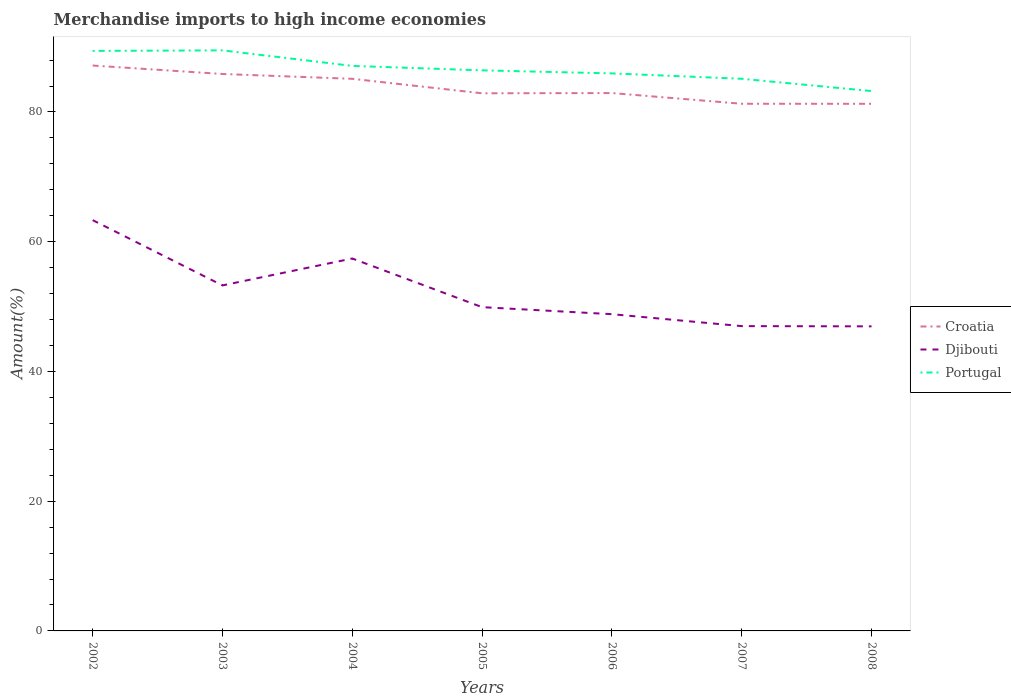How many different coloured lines are there?
Make the answer very short. 3. Is the number of lines equal to the number of legend labels?
Offer a terse response. Yes. Across all years, what is the maximum percentage of amount earned from merchandise imports in Djibouti?
Offer a very short reply. 46.95. In which year was the percentage of amount earned from merchandise imports in Croatia maximum?
Provide a short and direct response. 2008. What is the total percentage of amount earned from merchandise imports in Portugal in the graph?
Provide a succinct answer. 6.27. What is the difference between the highest and the second highest percentage of amount earned from merchandise imports in Portugal?
Offer a very short reply. 6.27. What is the difference between the highest and the lowest percentage of amount earned from merchandise imports in Djibouti?
Your answer should be compact. 3. What is the difference between two consecutive major ticks on the Y-axis?
Ensure brevity in your answer.  20. Are the values on the major ticks of Y-axis written in scientific E-notation?
Keep it short and to the point. No. Where does the legend appear in the graph?
Your response must be concise. Center right. How many legend labels are there?
Keep it short and to the point. 3. How are the legend labels stacked?
Provide a short and direct response. Vertical. What is the title of the graph?
Ensure brevity in your answer.  Merchandise imports to high income economies. Does "Mexico" appear as one of the legend labels in the graph?
Keep it short and to the point. No. What is the label or title of the X-axis?
Keep it short and to the point. Years. What is the label or title of the Y-axis?
Give a very brief answer. Amount(%). What is the Amount(%) of Croatia in 2002?
Ensure brevity in your answer.  87.16. What is the Amount(%) in Djibouti in 2002?
Your answer should be very brief. 63.33. What is the Amount(%) in Portugal in 2002?
Keep it short and to the point. 89.41. What is the Amount(%) in Croatia in 2003?
Make the answer very short. 85.85. What is the Amount(%) of Djibouti in 2003?
Keep it short and to the point. 53.26. What is the Amount(%) in Portugal in 2003?
Keep it short and to the point. 89.5. What is the Amount(%) in Croatia in 2004?
Give a very brief answer. 85.11. What is the Amount(%) of Djibouti in 2004?
Your answer should be compact. 57.41. What is the Amount(%) in Portugal in 2004?
Provide a succinct answer. 87.1. What is the Amount(%) in Croatia in 2005?
Provide a short and direct response. 82.88. What is the Amount(%) in Djibouti in 2005?
Provide a short and direct response. 49.91. What is the Amount(%) of Portugal in 2005?
Your answer should be compact. 86.41. What is the Amount(%) in Croatia in 2006?
Ensure brevity in your answer.  82.92. What is the Amount(%) in Djibouti in 2006?
Ensure brevity in your answer.  48.83. What is the Amount(%) of Portugal in 2006?
Offer a very short reply. 85.95. What is the Amount(%) of Croatia in 2007?
Keep it short and to the point. 81.27. What is the Amount(%) in Djibouti in 2007?
Provide a succinct answer. 46.99. What is the Amount(%) in Portugal in 2007?
Ensure brevity in your answer.  85.12. What is the Amount(%) of Croatia in 2008?
Make the answer very short. 81.26. What is the Amount(%) in Djibouti in 2008?
Provide a short and direct response. 46.95. What is the Amount(%) in Portugal in 2008?
Your answer should be compact. 83.22. Across all years, what is the maximum Amount(%) in Croatia?
Ensure brevity in your answer.  87.16. Across all years, what is the maximum Amount(%) of Djibouti?
Offer a very short reply. 63.33. Across all years, what is the maximum Amount(%) in Portugal?
Ensure brevity in your answer.  89.5. Across all years, what is the minimum Amount(%) in Croatia?
Your answer should be compact. 81.26. Across all years, what is the minimum Amount(%) in Djibouti?
Make the answer very short. 46.95. Across all years, what is the minimum Amount(%) in Portugal?
Offer a very short reply. 83.22. What is the total Amount(%) of Croatia in the graph?
Make the answer very short. 586.45. What is the total Amount(%) of Djibouti in the graph?
Your answer should be compact. 366.68. What is the total Amount(%) in Portugal in the graph?
Provide a short and direct response. 606.71. What is the difference between the Amount(%) in Croatia in 2002 and that in 2003?
Make the answer very short. 1.3. What is the difference between the Amount(%) of Djibouti in 2002 and that in 2003?
Make the answer very short. 10.06. What is the difference between the Amount(%) of Portugal in 2002 and that in 2003?
Give a very brief answer. -0.08. What is the difference between the Amount(%) in Croatia in 2002 and that in 2004?
Your answer should be very brief. 2.05. What is the difference between the Amount(%) of Djibouti in 2002 and that in 2004?
Offer a very short reply. 5.92. What is the difference between the Amount(%) of Portugal in 2002 and that in 2004?
Your answer should be compact. 2.31. What is the difference between the Amount(%) of Croatia in 2002 and that in 2005?
Provide a succinct answer. 4.28. What is the difference between the Amount(%) in Djibouti in 2002 and that in 2005?
Ensure brevity in your answer.  13.41. What is the difference between the Amount(%) in Portugal in 2002 and that in 2005?
Your response must be concise. 3. What is the difference between the Amount(%) in Croatia in 2002 and that in 2006?
Provide a short and direct response. 4.24. What is the difference between the Amount(%) in Djibouti in 2002 and that in 2006?
Ensure brevity in your answer.  14.5. What is the difference between the Amount(%) in Portugal in 2002 and that in 2006?
Your answer should be compact. 3.46. What is the difference between the Amount(%) in Croatia in 2002 and that in 2007?
Provide a short and direct response. 5.89. What is the difference between the Amount(%) in Djibouti in 2002 and that in 2007?
Provide a short and direct response. 16.34. What is the difference between the Amount(%) of Portugal in 2002 and that in 2007?
Keep it short and to the point. 4.29. What is the difference between the Amount(%) of Croatia in 2002 and that in 2008?
Provide a short and direct response. 5.9. What is the difference between the Amount(%) in Djibouti in 2002 and that in 2008?
Offer a very short reply. 16.37. What is the difference between the Amount(%) of Portugal in 2002 and that in 2008?
Your answer should be compact. 6.19. What is the difference between the Amount(%) in Croatia in 2003 and that in 2004?
Provide a short and direct response. 0.74. What is the difference between the Amount(%) of Djibouti in 2003 and that in 2004?
Your response must be concise. -4.15. What is the difference between the Amount(%) of Portugal in 2003 and that in 2004?
Your answer should be compact. 2.39. What is the difference between the Amount(%) in Croatia in 2003 and that in 2005?
Offer a terse response. 2.97. What is the difference between the Amount(%) of Djibouti in 2003 and that in 2005?
Keep it short and to the point. 3.35. What is the difference between the Amount(%) of Portugal in 2003 and that in 2005?
Keep it short and to the point. 3.08. What is the difference between the Amount(%) of Croatia in 2003 and that in 2006?
Offer a terse response. 2.94. What is the difference between the Amount(%) of Djibouti in 2003 and that in 2006?
Keep it short and to the point. 4.43. What is the difference between the Amount(%) in Portugal in 2003 and that in 2006?
Your response must be concise. 3.55. What is the difference between the Amount(%) in Croatia in 2003 and that in 2007?
Provide a short and direct response. 4.59. What is the difference between the Amount(%) of Djibouti in 2003 and that in 2007?
Provide a succinct answer. 6.28. What is the difference between the Amount(%) in Portugal in 2003 and that in 2007?
Offer a very short reply. 4.38. What is the difference between the Amount(%) of Croatia in 2003 and that in 2008?
Provide a short and direct response. 4.6. What is the difference between the Amount(%) in Djibouti in 2003 and that in 2008?
Offer a very short reply. 6.31. What is the difference between the Amount(%) in Portugal in 2003 and that in 2008?
Offer a very short reply. 6.27. What is the difference between the Amount(%) in Croatia in 2004 and that in 2005?
Offer a terse response. 2.23. What is the difference between the Amount(%) in Djibouti in 2004 and that in 2005?
Offer a terse response. 7.5. What is the difference between the Amount(%) in Portugal in 2004 and that in 2005?
Make the answer very short. 0.69. What is the difference between the Amount(%) of Croatia in 2004 and that in 2006?
Provide a short and direct response. 2.2. What is the difference between the Amount(%) in Djibouti in 2004 and that in 2006?
Your response must be concise. 8.58. What is the difference between the Amount(%) in Portugal in 2004 and that in 2006?
Your answer should be very brief. 1.15. What is the difference between the Amount(%) of Croatia in 2004 and that in 2007?
Give a very brief answer. 3.85. What is the difference between the Amount(%) of Djibouti in 2004 and that in 2007?
Your answer should be compact. 10.42. What is the difference between the Amount(%) in Portugal in 2004 and that in 2007?
Provide a succinct answer. 1.98. What is the difference between the Amount(%) of Croatia in 2004 and that in 2008?
Your answer should be very brief. 3.85. What is the difference between the Amount(%) of Djibouti in 2004 and that in 2008?
Make the answer very short. 10.46. What is the difference between the Amount(%) of Portugal in 2004 and that in 2008?
Your answer should be compact. 3.88. What is the difference between the Amount(%) in Croatia in 2005 and that in 2006?
Provide a short and direct response. -0.04. What is the difference between the Amount(%) in Djibouti in 2005 and that in 2006?
Offer a very short reply. 1.08. What is the difference between the Amount(%) in Portugal in 2005 and that in 2006?
Provide a succinct answer. 0.47. What is the difference between the Amount(%) of Croatia in 2005 and that in 2007?
Give a very brief answer. 1.61. What is the difference between the Amount(%) of Djibouti in 2005 and that in 2007?
Ensure brevity in your answer.  2.93. What is the difference between the Amount(%) in Portugal in 2005 and that in 2007?
Your response must be concise. 1.3. What is the difference between the Amount(%) in Croatia in 2005 and that in 2008?
Offer a terse response. 1.62. What is the difference between the Amount(%) in Djibouti in 2005 and that in 2008?
Ensure brevity in your answer.  2.96. What is the difference between the Amount(%) in Portugal in 2005 and that in 2008?
Ensure brevity in your answer.  3.19. What is the difference between the Amount(%) in Croatia in 2006 and that in 2007?
Ensure brevity in your answer.  1.65. What is the difference between the Amount(%) of Djibouti in 2006 and that in 2007?
Provide a succinct answer. 1.84. What is the difference between the Amount(%) in Portugal in 2006 and that in 2007?
Your answer should be very brief. 0.83. What is the difference between the Amount(%) of Croatia in 2006 and that in 2008?
Your response must be concise. 1.66. What is the difference between the Amount(%) of Djibouti in 2006 and that in 2008?
Provide a succinct answer. 1.88. What is the difference between the Amount(%) in Portugal in 2006 and that in 2008?
Your answer should be compact. 2.72. What is the difference between the Amount(%) of Croatia in 2007 and that in 2008?
Provide a succinct answer. 0.01. What is the difference between the Amount(%) of Djibouti in 2007 and that in 2008?
Ensure brevity in your answer.  0.04. What is the difference between the Amount(%) in Portugal in 2007 and that in 2008?
Keep it short and to the point. 1.89. What is the difference between the Amount(%) of Croatia in 2002 and the Amount(%) of Djibouti in 2003?
Keep it short and to the point. 33.9. What is the difference between the Amount(%) in Croatia in 2002 and the Amount(%) in Portugal in 2003?
Your response must be concise. -2.34. What is the difference between the Amount(%) of Djibouti in 2002 and the Amount(%) of Portugal in 2003?
Provide a short and direct response. -26.17. What is the difference between the Amount(%) of Croatia in 2002 and the Amount(%) of Djibouti in 2004?
Make the answer very short. 29.75. What is the difference between the Amount(%) of Croatia in 2002 and the Amount(%) of Portugal in 2004?
Offer a terse response. 0.06. What is the difference between the Amount(%) in Djibouti in 2002 and the Amount(%) in Portugal in 2004?
Your response must be concise. -23.78. What is the difference between the Amount(%) of Croatia in 2002 and the Amount(%) of Djibouti in 2005?
Your response must be concise. 37.25. What is the difference between the Amount(%) in Croatia in 2002 and the Amount(%) in Portugal in 2005?
Ensure brevity in your answer.  0.74. What is the difference between the Amount(%) in Djibouti in 2002 and the Amount(%) in Portugal in 2005?
Your answer should be compact. -23.09. What is the difference between the Amount(%) in Croatia in 2002 and the Amount(%) in Djibouti in 2006?
Provide a succinct answer. 38.33. What is the difference between the Amount(%) in Croatia in 2002 and the Amount(%) in Portugal in 2006?
Keep it short and to the point. 1.21. What is the difference between the Amount(%) of Djibouti in 2002 and the Amount(%) of Portugal in 2006?
Ensure brevity in your answer.  -22.62. What is the difference between the Amount(%) in Croatia in 2002 and the Amount(%) in Djibouti in 2007?
Offer a very short reply. 40.17. What is the difference between the Amount(%) in Croatia in 2002 and the Amount(%) in Portugal in 2007?
Offer a terse response. 2.04. What is the difference between the Amount(%) of Djibouti in 2002 and the Amount(%) of Portugal in 2007?
Your answer should be compact. -21.79. What is the difference between the Amount(%) in Croatia in 2002 and the Amount(%) in Djibouti in 2008?
Your answer should be compact. 40.21. What is the difference between the Amount(%) in Croatia in 2002 and the Amount(%) in Portugal in 2008?
Provide a short and direct response. 3.94. What is the difference between the Amount(%) of Djibouti in 2002 and the Amount(%) of Portugal in 2008?
Your answer should be very brief. -19.9. What is the difference between the Amount(%) of Croatia in 2003 and the Amount(%) of Djibouti in 2004?
Offer a terse response. 28.44. What is the difference between the Amount(%) of Croatia in 2003 and the Amount(%) of Portugal in 2004?
Provide a short and direct response. -1.25. What is the difference between the Amount(%) of Djibouti in 2003 and the Amount(%) of Portugal in 2004?
Your response must be concise. -33.84. What is the difference between the Amount(%) of Croatia in 2003 and the Amount(%) of Djibouti in 2005?
Offer a very short reply. 35.94. What is the difference between the Amount(%) in Croatia in 2003 and the Amount(%) in Portugal in 2005?
Your answer should be compact. -0.56. What is the difference between the Amount(%) of Djibouti in 2003 and the Amount(%) of Portugal in 2005?
Your response must be concise. -33.15. What is the difference between the Amount(%) of Croatia in 2003 and the Amount(%) of Djibouti in 2006?
Give a very brief answer. 37.03. What is the difference between the Amount(%) in Croatia in 2003 and the Amount(%) in Portugal in 2006?
Ensure brevity in your answer.  -0.09. What is the difference between the Amount(%) of Djibouti in 2003 and the Amount(%) of Portugal in 2006?
Offer a terse response. -32.69. What is the difference between the Amount(%) in Croatia in 2003 and the Amount(%) in Djibouti in 2007?
Offer a very short reply. 38.87. What is the difference between the Amount(%) in Croatia in 2003 and the Amount(%) in Portugal in 2007?
Your response must be concise. 0.74. What is the difference between the Amount(%) in Djibouti in 2003 and the Amount(%) in Portugal in 2007?
Give a very brief answer. -31.85. What is the difference between the Amount(%) of Croatia in 2003 and the Amount(%) of Djibouti in 2008?
Your response must be concise. 38.9. What is the difference between the Amount(%) of Croatia in 2003 and the Amount(%) of Portugal in 2008?
Offer a very short reply. 2.63. What is the difference between the Amount(%) of Djibouti in 2003 and the Amount(%) of Portugal in 2008?
Provide a short and direct response. -29.96. What is the difference between the Amount(%) in Croatia in 2004 and the Amount(%) in Djibouti in 2005?
Offer a very short reply. 35.2. What is the difference between the Amount(%) in Croatia in 2004 and the Amount(%) in Portugal in 2005?
Your response must be concise. -1.3. What is the difference between the Amount(%) of Djibouti in 2004 and the Amount(%) of Portugal in 2005?
Provide a short and direct response. -29.01. What is the difference between the Amount(%) in Croatia in 2004 and the Amount(%) in Djibouti in 2006?
Give a very brief answer. 36.28. What is the difference between the Amount(%) in Croatia in 2004 and the Amount(%) in Portugal in 2006?
Offer a very short reply. -0.84. What is the difference between the Amount(%) in Djibouti in 2004 and the Amount(%) in Portugal in 2006?
Your answer should be very brief. -28.54. What is the difference between the Amount(%) of Croatia in 2004 and the Amount(%) of Djibouti in 2007?
Keep it short and to the point. 38.13. What is the difference between the Amount(%) of Croatia in 2004 and the Amount(%) of Portugal in 2007?
Your answer should be very brief. -0. What is the difference between the Amount(%) of Djibouti in 2004 and the Amount(%) of Portugal in 2007?
Provide a short and direct response. -27.71. What is the difference between the Amount(%) of Croatia in 2004 and the Amount(%) of Djibouti in 2008?
Ensure brevity in your answer.  38.16. What is the difference between the Amount(%) of Croatia in 2004 and the Amount(%) of Portugal in 2008?
Provide a succinct answer. 1.89. What is the difference between the Amount(%) of Djibouti in 2004 and the Amount(%) of Portugal in 2008?
Give a very brief answer. -25.81. What is the difference between the Amount(%) of Croatia in 2005 and the Amount(%) of Djibouti in 2006?
Your answer should be compact. 34.05. What is the difference between the Amount(%) in Croatia in 2005 and the Amount(%) in Portugal in 2006?
Ensure brevity in your answer.  -3.07. What is the difference between the Amount(%) in Djibouti in 2005 and the Amount(%) in Portugal in 2006?
Your answer should be very brief. -36.04. What is the difference between the Amount(%) of Croatia in 2005 and the Amount(%) of Djibouti in 2007?
Give a very brief answer. 35.89. What is the difference between the Amount(%) in Croatia in 2005 and the Amount(%) in Portugal in 2007?
Keep it short and to the point. -2.24. What is the difference between the Amount(%) in Djibouti in 2005 and the Amount(%) in Portugal in 2007?
Give a very brief answer. -35.2. What is the difference between the Amount(%) of Croatia in 2005 and the Amount(%) of Djibouti in 2008?
Your answer should be very brief. 35.93. What is the difference between the Amount(%) in Croatia in 2005 and the Amount(%) in Portugal in 2008?
Give a very brief answer. -0.34. What is the difference between the Amount(%) in Djibouti in 2005 and the Amount(%) in Portugal in 2008?
Offer a very short reply. -33.31. What is the difference between the Amount(%) of Croatia in 2006 and the Amount(%) of Djibouti in 2007?
Make the answer very short. 35.93. What is the difference between the Amount(%) of Croatia in 2006 and the Amount(%) of Portugal in 2007?
Provide a succinct answer. -2.2. What is the difference between the Amount(%) of Djibouti in 2006 and the Amount(%) of Portugal in 2007?
Keep it short and to the point. -36.29. What is the difference between the Amount(%) in Croatia in 2006 and the Amount(%) in Djibouti in 2008?
Your answer should be very brief. 35.96. What is the difference between the Amount(%) in Croatia in 2006 and the Amount(%) in Portugal in 2008?
Your answer should be very brief. -0.31. What is the difference between the Amount(%) of Djibouti in 2006 and the Amount(%) of Portugal in 2008?
Keep it short and to the point. -34.4. What is the difference between the Amount(%) of Croatia in 2007 and the Amount(%) of Djibouti in 2008?
Your answer should be compact. 34.31. What is the difference between the Amount(%) in Croatia in 2007 and the Amount(%) in Portugal in 2008?
Make the answer very short. -1.96. What is the difference between the Amount(%) in Djibouti in 2007 and the Amount(%) in Portugal in 2008?
Provide a succinct answer. -36.24. What is the average Amount(%) of Croatia per year?
Offer a terse response. 83.78. What is the average Amount(%) of Djibouti per year?
Make the answer very short. 52.38. What is the average Amount(%) in Portugal per year?
Give a very brief answer. 86.67. In the year 2002, what is the difference between the Amount(%) in Croatia and Amount(%) in Djibouti?
Offer a very short reply. 23.83. In the year 2002, what is the difference between the Amount(%) of Croatia and Amount(%) of Portugal?
Provide a succinct answer. -2.25. In the year 2002, what is the difference between the Amount(%) of Djibouti and Amount(%) of Portugal?
Offer a very short reply. -26.09. In the year 2003, what is the difference between the Amount(%) in Croatia and Amount(%) in Djibouti?
Give a very brief answer. 32.59. In the year 2003, what is the difference between the Amount(%) of Croatia and Amount(%) of Portugal?
Your answer should be compact. -3.64. In the year 2003, what is the difference between the Amount(%) of Djibouti and Amount(%) of Portugal?
Offer a terse response. -36.23. In the year 2004, what is the difference between the Amount(%) in Croatia and Amount(%) in Djibouti?
Provide a succinct answer. 27.7. In the year 2004, what is the difference between the Amount(%) of Croatia and Amount(%) of Portugal?
Your answer should be compact. -1.99. In the year 2004, what is the difference between the Amount(%) of Djibouti and Amount(%) of Portugal?
Provide a succinct answer. -29.69. In the year 2005, what is the difference between the Amount(%) in Croatia and Amount(%) in Djibouti?
Offer a very short reply. 32.97. In the year 2005, what is the difference between the Amount(%) of Croatia and Amount(%) of Portugal?
Offer a terse response. -3.53. In the year 2005, what is the difference between the Amount(%) in Djibouti and Amount(%) in Portugal?
Your response must be concise. -36.5. In the year 2006, what is the difference between the Amount(%) in Croatia and Amount(%) in Djibouti?
Give a very brief answer. 34.09. In the year 2006, what is the difference between the Amount(%) in Croatia and Amount(%) in Portugal?
Offer a very short reply. -3.03. In the year 2006, what is the difference between the Amount(%) of Djibouti and Amount(%) of Portugal?
Your answer should be compact. -37.12. In the year 2007, what is the difference between the Amount(%) in Croatia and Amount(%) in Djibouti?
Your answer should be compact. 34.28. In the year 2007, what is the difference between the Amount(%) in Croatia and Amount(%) in Portugal?
Make the answer very short. -3.85. In the year 2007, what is the difference between the Amount(%) of Djibouti and Amount(%) of Portugal?
Keep it short and to the point. -38.13. In the year 2008, what is the difference between the Amount(%) in Croatia and Amount(%) in Djibouti?
Make the answer very short. 34.31. In the year 2008, what is the difference between the Amount(%) in Croatia and Amount(%) in Portugal?
Ensure brevity in your answer.  -1.96. In the year 2008, what is the difference between the Amount(%) in Djibouti and Amount(%) in Portugal?
Offer a very short reply. -36.27. What is the ratio of the Amount(%) in Croatia in 2002 to that in 2003?
Offer a very short reply. 1.02. What is the ratio of the Amount(%) in Djibouti in 2002 to that in 2003?
Your answer should be very brief. 1.19. What is the ratio of the Amount(%) of Portugal in 2002 to that in 2003?
Offer a very short reply. 1. What is the ratio of the Amount(%) in Croatia in 2002 to that in 2004?
Provide a short and direct response. 1.02. What is the ratio of the Amount(%) in Djibouti in 2002 to that in 2004?
Your answer should be very brief. 1.1. What is the ratio of the Amount(%) of Portugal in 2002 to that in 2004?
Offer a very short reply. 1.03. What is the ratio of the Amount(%) in Croatia in 2002 to that in 2005?
Your answer should be very brief. 1.05. What is the ratio of the Amount(%) of Djibouti in 2002 to that in 2005?
Provide a succinct answer. 1.27. What is the ratio of the Amount(%) of Portugal in 2002 to that in 2005?
Give a very brief answer. 1.03. What is the ratio of the Amount(%) of Croatia in 2002 to that in 2006?
Your response must be concise. 1.05. What is the ratio of the Amount(%) of Djibouti in 2002 to that in 2006?
Keep it short and to the point. 1.3. What is the ratio of the Amount(%) of Portugal in 2002 to that in 2006?
Ensure brevity in your answer.  1.04. What is the ratio of the Amount(%) in Croatia in 2002 to that in 2007?
Your answer should be very brief. 1.07. What is the ratio of the Amount(%) in Djibouti in 2002 to that in 2007?
Your answer should be very brief. 1.35. What is the ratio of the Amount(%) of Portugal in 2002 to that in 2007?
Provide a short and direct response. 1.05. What is the ratio of the Amount(%) in Croatia in 2002 to that in 2008?
Provide a succinct answer. 1.07. What is the ratio of the Amount(%) of Djibouti in 2002 to that in 2008?
Your answer should be compact. 1.35. What is the ratio of the Amount(%) in Portugal in 2002 to that in 2008?
Ensure brevity in your answer.  1.07. What is the ratio of the Amount(%) of Croatia in 2003 to that in 2004?
Provide a short and direct response. 1.01. What is the ratio of the Amount(%) of Djibouti in 2003 to that in 2004?
Your answer should be very brief. 0.93. What is the ratio of the Amount(%) of Portugal in 2003 to that in 2004?
Offer a very short reply. 1.03. What is the ratio of the Amount(%) in Croatia in 2003 to that in 2005?
Offer a terse response. 1.04. What is the ratio of the Amount(%) in Djibouti in 2003 to that in 2005?
Make the answer very short. 1.07. What is the ratio of the Amount(%) in Portugal in 2003 to that in 2005?
Offer a terse response. 1.04. What is the ratio of the Amount(%) of Croatia in 2003 to that in 2006?
Your answer should be compact. 1.04. What is the ratio of the Amount(%) in Djibouti in 2003 to that in 2006?
Make the answer very short. 1.09. What is the ratio of the Amount(%) of Portugal in 2003 to that in 2006?
Your answer should be very brief. 1.04. What is the ratio of the Amount(%) of Croatia in 2003 to that in 2007?
Provide a short and direct response. 1.06. What is the ratio of the Amount(%) in Djibouti in 2003 to that in 2007?
Make the answer very short. 1.13. What is the ratio of the Amount(%) of Portugal in 2003 to that in 2007?
Give a very brief answer. 1.05. What is the ratio of the Amount(%) of Croatia in 2003 to that in 2008?
Your answer should be compact. 1.06. What is the ratio of the Amount(%) in Djibouti in 2003 to that in 2008?
Make the answer very short. 1.13. What is the ratio of the Amount(%) in Portugal in 2003 to that in 2008?
Your answer should be very brief. 1.08. What is the ratio of the Amount(%) in Croatia in 2004 to that in 2005?
Offer a very short reply. 1.03. What is the ratio of the Amount(%) in Djibouti in 2004 to that in 2005?
Make the answer very short. 1.15. What is the ratio of the Amount(%) of Portugal in 2004 to that in 2005?
Keep it short and to the point. 1.01. What is the ratio of the Amount(%) of Croatia in 2004 to that in 2006?
Offer a very short reply. 1.03. What is the ratio of the Amount(%) of Djibouti in 2004 to that in 2006?
Offer a very short reply. 1.18. What is the ratio of the Amount(%) in Portugal in 2004 to that in 2006?
Offer a very short reply. 1.01. What is the ratio of the Amount(%) of Croatia in 2004 to that in 2007?
Your response must be concise. 1.05. What is the ratio of the Amount(%) of Djibouti in 2004 to that in 2007?
Give a very brief answer. 1.22. What is the ratio of the Amount(%) in Portugal in 2004 to that in 2007?
Offer a very short reply. 1.02. What is the ratio of the Amount(%) of Croatia in 2004 to that in 2008?
Offer a terse response. 1.05. What is the ratio of the Amount(%) in Djibouti in 2004 to that in 2008?
Provide a short and direct response. 1.22. What is the ratio of the Amount(%) in Portugal in 2004 to that in 2008?
Provide a short and direct response. 1.05. What is the ratio of the Amount(%) of Djibouti in 2005 to that in 2006?
Offer a terse response. 1.02. What is the ratio of the Amount(%) of Portugal in 2005 to that in 2006?
Provide a succinct answer. 1.01. What is the ratio of the Amount(%) in Croatia in 2005 to that in 2007?
Provide a short and direct response. 1.02. What is the ratio of the Amount(%) of Djibouti in 2005 to that in 2007?
Ensure brevity in your answer.  1.06. What is the ratio of the Amount(%) in Portugal in 2005 to that in 2007?
Offer a terse response. 1.02. What is the ratio of the Amount(%) of Croatia in 2005 to that in 2008?
Your response must be concise. 1.02. What is the ratio of the Amount(%) in Djibouti in 2005 to that in 2008?
Your answer should be compact. 1.06. What is the ratio of the Amount(%) in Portugal in 2005 to that in 2008?
Your answer should be compact. 1.04. What is the ratio of the Amount(%) of Croatia in 2006 to that in 2007?
Ensure brevity in your answer.  1.02. What is the ratio of the Amount(%) in Djibouti in 2006 to that in 2007?
Ensure brevity in your answer.  1.04. What is the ratio of the Amount(%) in Portugal in 2006 to that in 2007?
Provide a succinct answer. 1.01. What is the ratio of the Amount(%) in Croatia in 2006 to that in 2008?
Your answer should be very brief. 1.02. What is the ratio of the Amount(%) in Djibouti in 2006 to that in 2008?
Your response must be concise. 1.04. What is the ratio of the Amount(%) in Portugal in 2006 to that in 2008?
Offer a terse response. 1.03. What is the ratio of the Amount(%) in Croatia in 2007 to that in 2008?
Ensure brevity in your answer.  1. What is the ratio of the Amount(%) of Djibouti in 2007 to that in 2008?
Offer a terse response. 1. What is the ratio of the Amount(%) in Portugal in 2007 to that in 2008?
Your response must be concise. 1.02. What is the difference between the highest and the second highest Amount(%) of Croatia?
Your answer should be compact. 1.3. What is the difference between the highest and the second highest Amount(%) of Djibouti?
Ensure brevity in your answer.  5.92. What is the difference between the highest and the second highest Amount(%) in Portugal?
Give a very brief answer. 0.08. What is the difference between the highest and the lowest Amount(%) in Croatia?
Your answer should be compact. 5.9. What is the difference between the highest and the lowest Amount(%) of Djibouti?
Offer a very short reply. 16.37. What is the difference between the highest and the lowest Amount(%) in Portugal?
Make the answer very short. 6.27. 